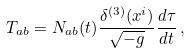Convert formula to latex. <formula><loc_0><loc_0><loc_500><loc_500>T _ { a b } = N _ { a b } ( t ) \frac { \delta ^ { ( 3 ) } ( x ^ { i } ) } { \sqrt { - g } } \frac { d \tau } { d t } \, ,</formula> 